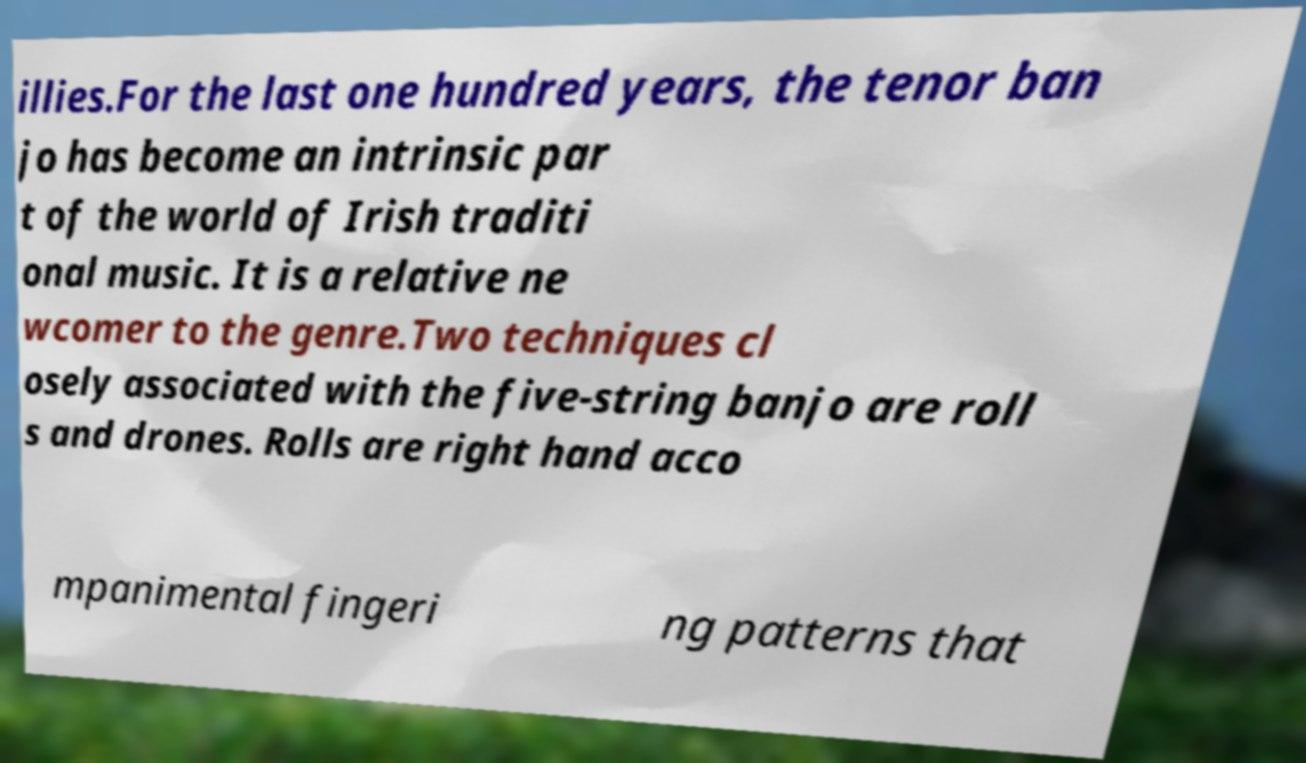There's text embedded in this image that I need extracted. Can you transcribe it verbatim? illies.For the last one hundred years, the tenor ban jo has become an intrinsic par t of the world of Irish traditi onal music. It is a relative ne wcomer to the genre.Two techniques cl osely associated with the five-string banjo are roll s and drones. Rolls are right hand acco mpanimental fingeri ng patterns that 